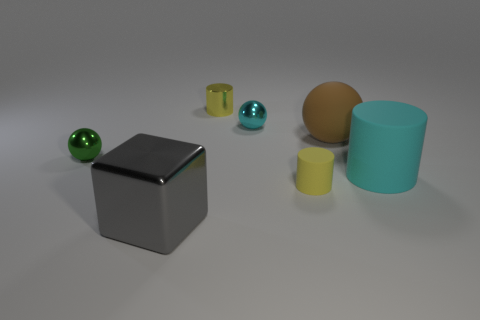Subtract 1 cylinders. How many cylinders are left? 2 Subtract all green shiny spheres. How many spheres are left? 2 Add 1 yellow metallic cylinders. How many objects exist? 8 Subtract all spheres. How many objects are left? 4 Subtract all brown metal spheres. Subtract all brown rubber balls. How many objects are left? 6 Add 1 small cylinders. How many small cylinders are left? 3 Add 2 tiny gray cubes. How many tiny gray cubes exist? 2 Subtract 0 purple balls. How many objects are left? 7 